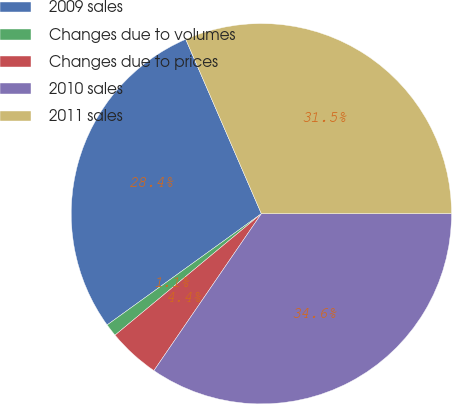Convert chart to OTSL. <chart><loc_0><loc_0><loc_500><loc_500><pie_chart><fcel>2009 sales<fcel>Changes due to volumes<fcel>Changes due to prices<fcel>2010 sales<fcel>2011 sales<nl><fcel>28.43%<fcel>1.08%<fcel>4.42%<fcel>34.57%<fcel>31.5%<nl></chart> 